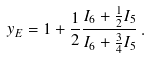<formula> <loc_0><loc_0><loc_500><loc_500>y _ { E } = 1 + \frac { 1 } { 2 } \frac { I _ { 6 } + \frac { 1 } { 2 } I _ { 5 } } { I _ { 6 } + \frac { 3 } { 4 } I _ { 5 } } \, .</formula> 